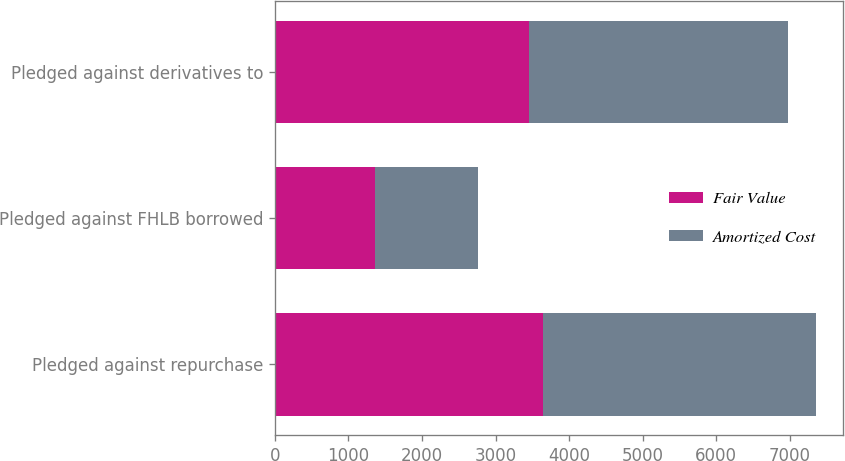<chart> <loc_0><loc_0><loc_500><loc_500><stacked_bar_chart><ecel><fcel>Pledged against repurchase<fcel>Pledged against FHLB borrowed<fcel>Pledged against derivatives to<nl><fcel>Fair Value<fcel>3650<fcel>1355<fcel>3453<nl><fcel>Amortized Cost<fcel>3701<fcel>1407<fcel>3520<nl></chart> 